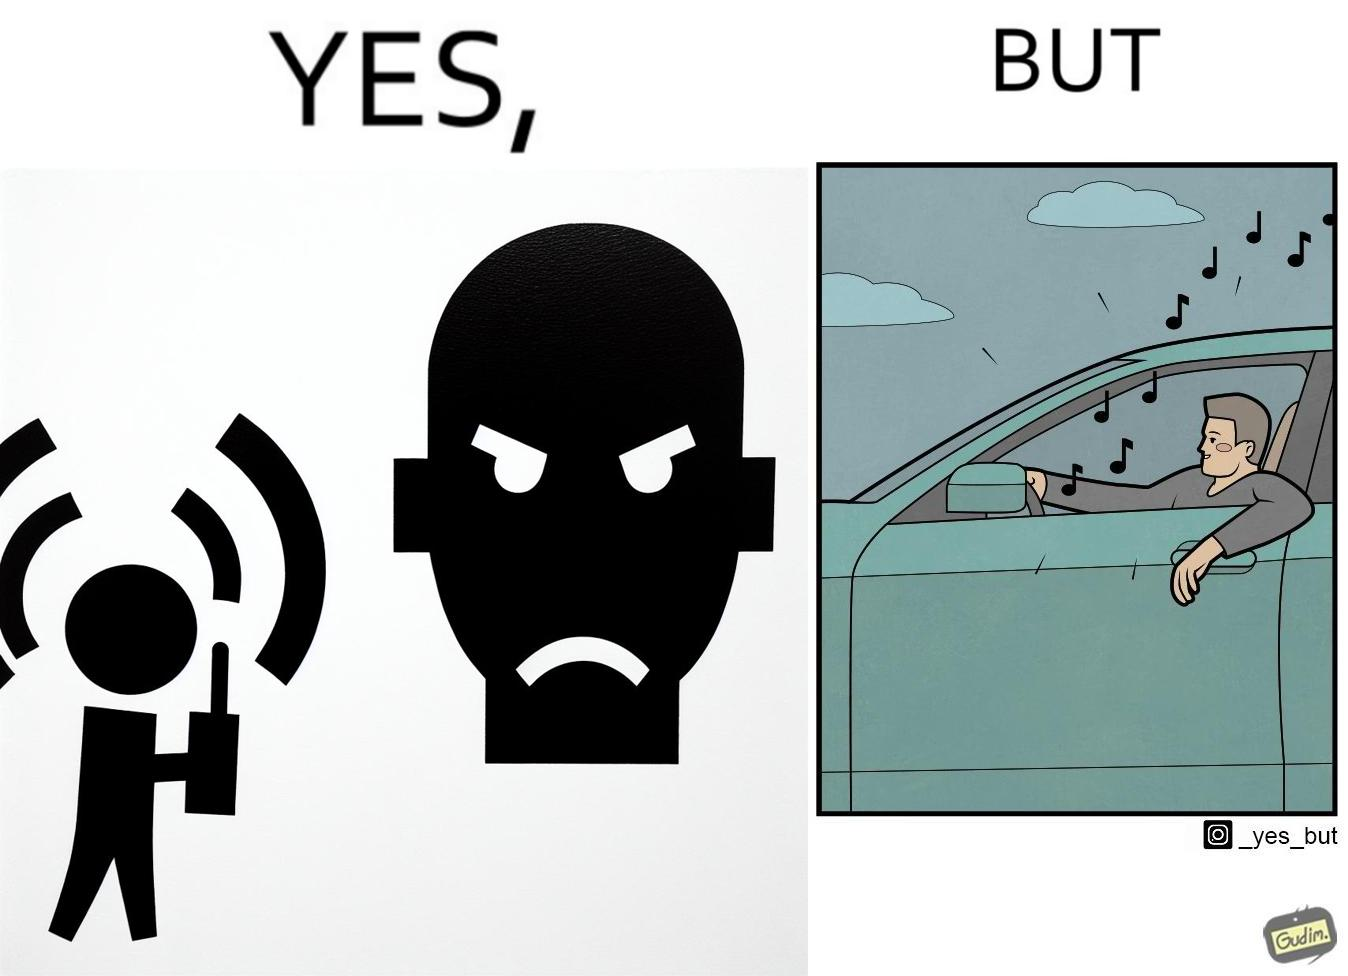What does this image depict? The image is funny because while the man does not like the boy playing music loudly on his phone, the man himself is okay with doing the same thing with his car and playing loud music in the car with the sound coming out of the car. 